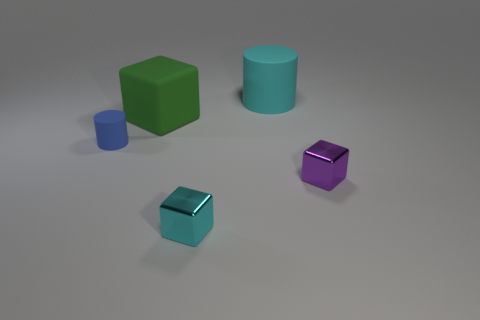How many things are either large matte cylinders or big objects that are to the right of the green matte thing?
Your answer should be very brief. 1. Does the large rubber cylinder have the same color as the tiny cylinder?
Provide a short and direct response. No. Is there a small cyan object that has the same material as the tiny cylinder?
Your answer should be very brief. No. What is the color of the other metal thing that is the same shape as the small cyan thing?
Provide a short and direct response. Purple. Do the big cylinder and the tiny thing that is on the left side of the big green object have the same material?
Keep it short and to the point. Yes. What is the shape of the cyan object behind the shiny block right of the small cyan shiny cube?
Your answer should be compact. Cylinder. Is the size of the shiny thing that is on the left side of the purple thing the same as the big cyan rubber cylinder?
Offer a terse response. No. How many other things are the same shape as the big cyan object?
Your response must be concise. 1. There is a cylinder left of the large green block; is it the same color as the matte block?
Make the answer very short. No. Are there any tiny metal blocks that have the same color as the big cube?
Your answer should be very brief. No. 